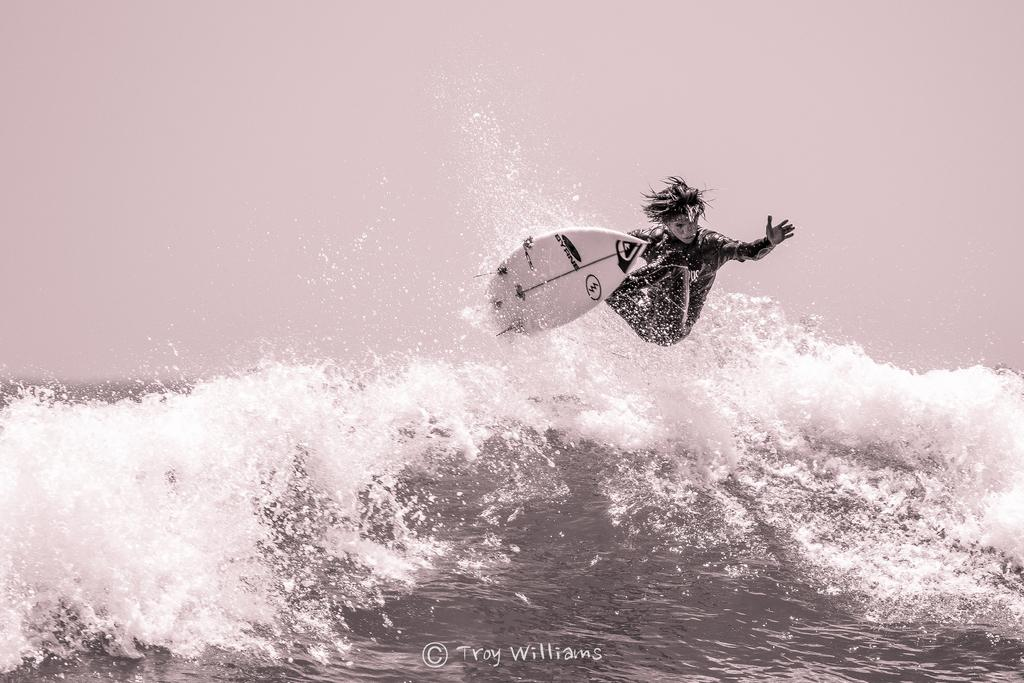What activity is the person in the image engaged in? The person is skiing in the image. Where is the person skiing? The person is skiing in the ocean. What is present at the bottom of the image? There is a logo and text at the bottom of the image. What can be seen at the top of the image? The sky is visible at the top of the image. What type of beast can be seen roaming in the ocean near the skier? There is no beast present in the image; it features a person skiing in the ocean. What event is taking place in the image? The image does not depict a specific event; it simply shows a person skiing in the ocean. 